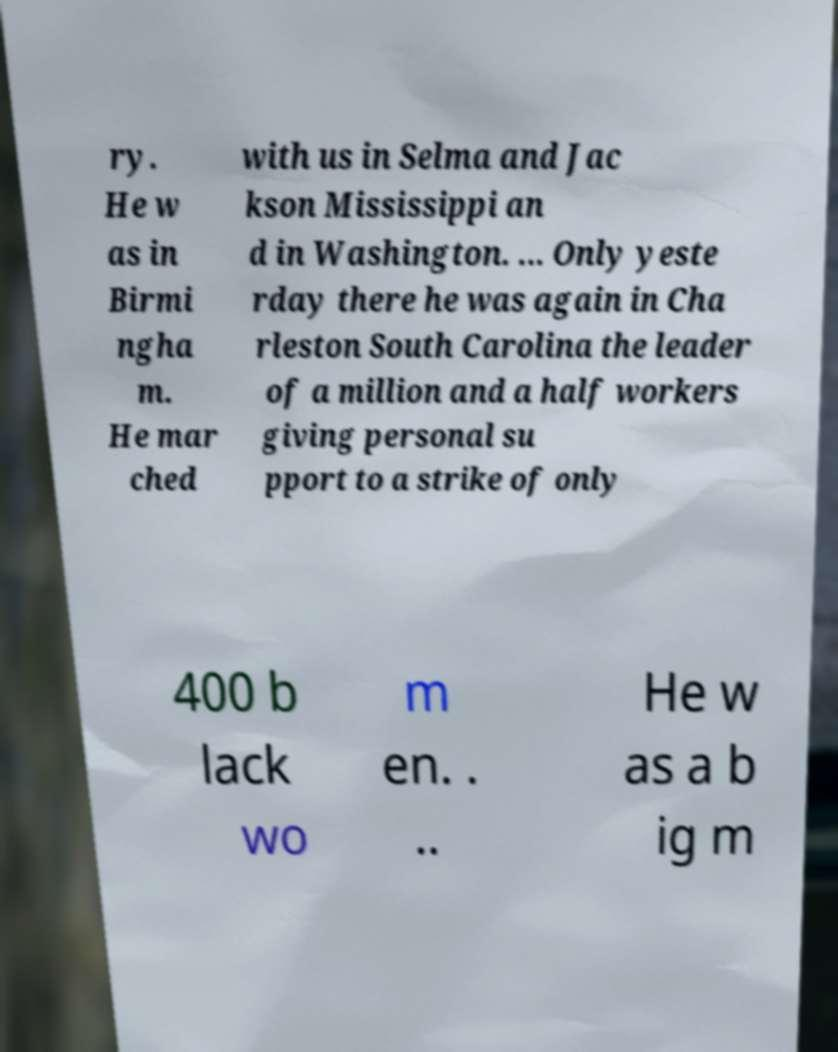Please identify and transcribe the text found in this image. ry. He w as in Birmi ngha m. He mar ched with us in Selma and Jac kson Mississippi an d in Washington. ... Only yeste rday there he was again in Cha rleston South Carolina the leader of a million and a half workers giving personal su pport to a strike of only 400 b lack wo m en. . .. He w as a b ig m 